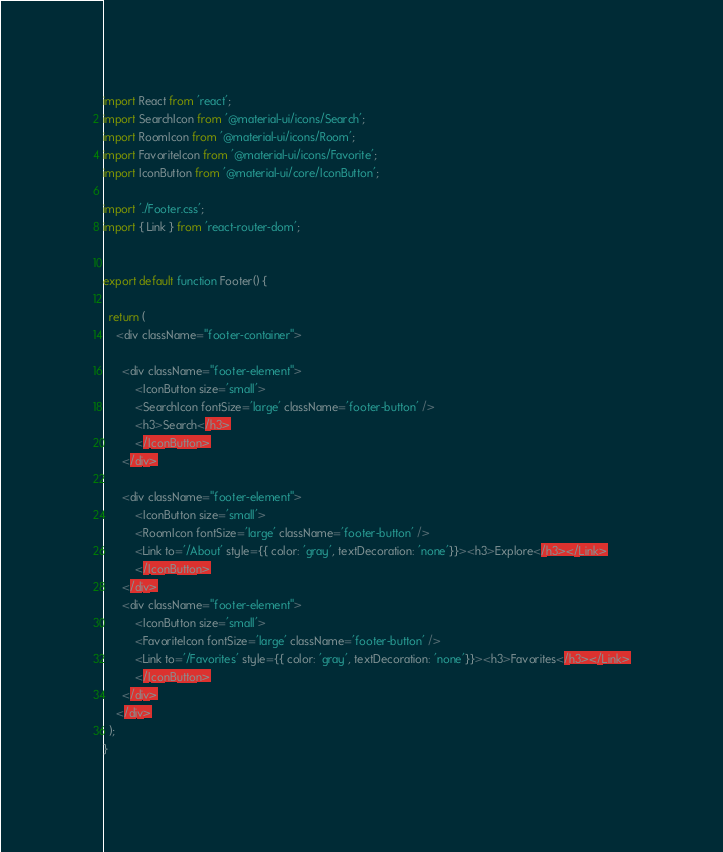Convert code to text. <code><loc_0><loc_0><loc_500><loc_500><_JavaScript_>import React from 'react';
import SearchIcon from '@material-ui/icons/Search';
import RoomIcon from '@material-ui/icons/Room';
import FavoriteIcon from '@material-ui/icons/Favorite';
import IconButton from '@material-ui/core/IconButton';

import './Footer.css';
import { Link } from 'react-router-dom'; 


export default function Footer() {

  return (
    <div className="footer-container">
   
      <div className="footer-element">
          <IconButton size='small'>
          <SearchIcon fontSize='large' className='footer-button' />
          <h3>Search</h3>
          </IconButton>
      </div>
     
      <div className="footer-element">
          <IconButton size='small'>
          <RoomIcon fontSize='large' className='footer-button' />
          <Link to='/About' style={{ color: 'gray', textDecoration: 'none'}}><h3>Explore</h3></Link>
          </IconButton>
      </div>
      <div className="footer-element">
          <IconButton size='small'>
          <FavoriteIcon fontSize='large' className='footer-button' />
          <Link to='/Favorites' style={{ color: 'gray', textDecoration: 'none'}}><h3>Favorites</h3></Link>
          </IconButton>
      </div>
    </div>
  );
}
</code> 